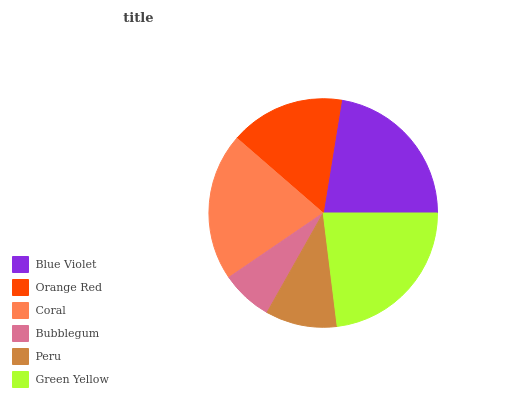Is Bubblegum the minimum?
Answer yes or no. Yes. Is Green Yellow the maximum?
Answer yes or no. Yes. Is Orange Red the minimum?
Answer yes or no. No. Is Orange Red the maximum?
Answer yes or no. No. Is Blue Violet greater than Orange Red?
Answer yes or no. Yes. Is Orange Red less than Blue Violet?
Answer yes or no. Yes. Is Orange Red greater than Blue Violet?
Answer yes or no. No. Is Blue Violet less than Orange Red?
Answer yes or no. No. Is Coral the high median?
Answer yes or no. Yes. Is Orange Red the low median?
Answer yes or no. Yes. Is Blue Violet the high median?
Answer yes or no. No. Is Green Yellow the low median?
Answer yes or no. No. 